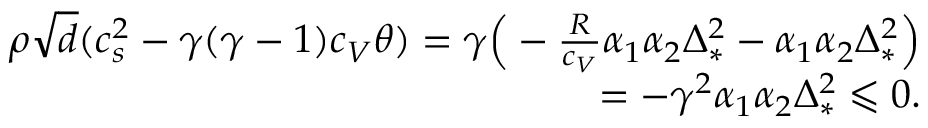<formula> <loc_0><loc_0><loc_500><loc_500>\begin{array} { r } { \rho \sqrt { d } ( c _ { s } ^ { 2 } - \gamma ( \gamma - 1 ) c _ { V } \theta ) = \gamma \left ( - \frac { R } { c _ { V } } \alpha _ { 1 } \alpha _ { 2 } \Delta _ { * } ^ { 2 } - \alpha _ { 1 } \alpha _ { 2 } \Delta _ { * } ^ { 2 } \right ) } \\ { = - \gamma ^ { 2 } \alpha _ { 1 } \alpha _ { 2 } \Delta _ { * } ^ { 2 } \leqslant 0 . } \end{array}</formula> 